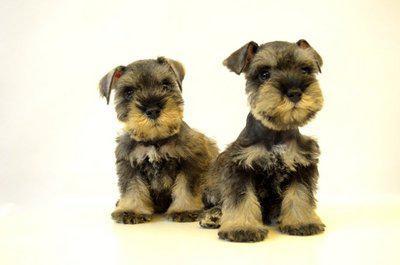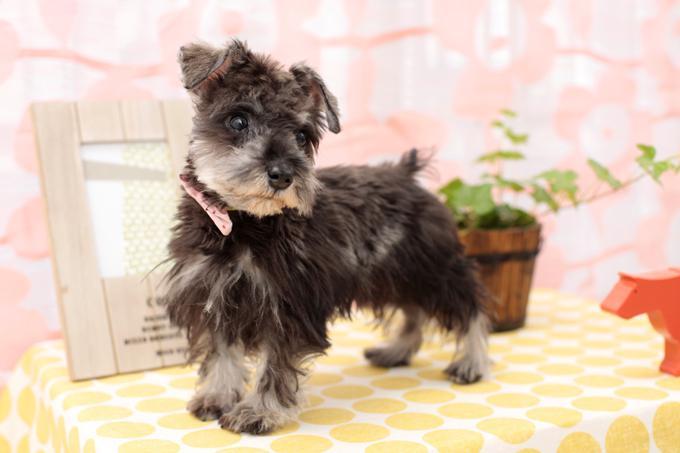The first image is the image on the left, the second image is the image on the right. Given the left and right images, does the statement "There is at least one dog completely surrounded by whiteness with no shadows of its tail." hold true? Answer yes or no. No. 